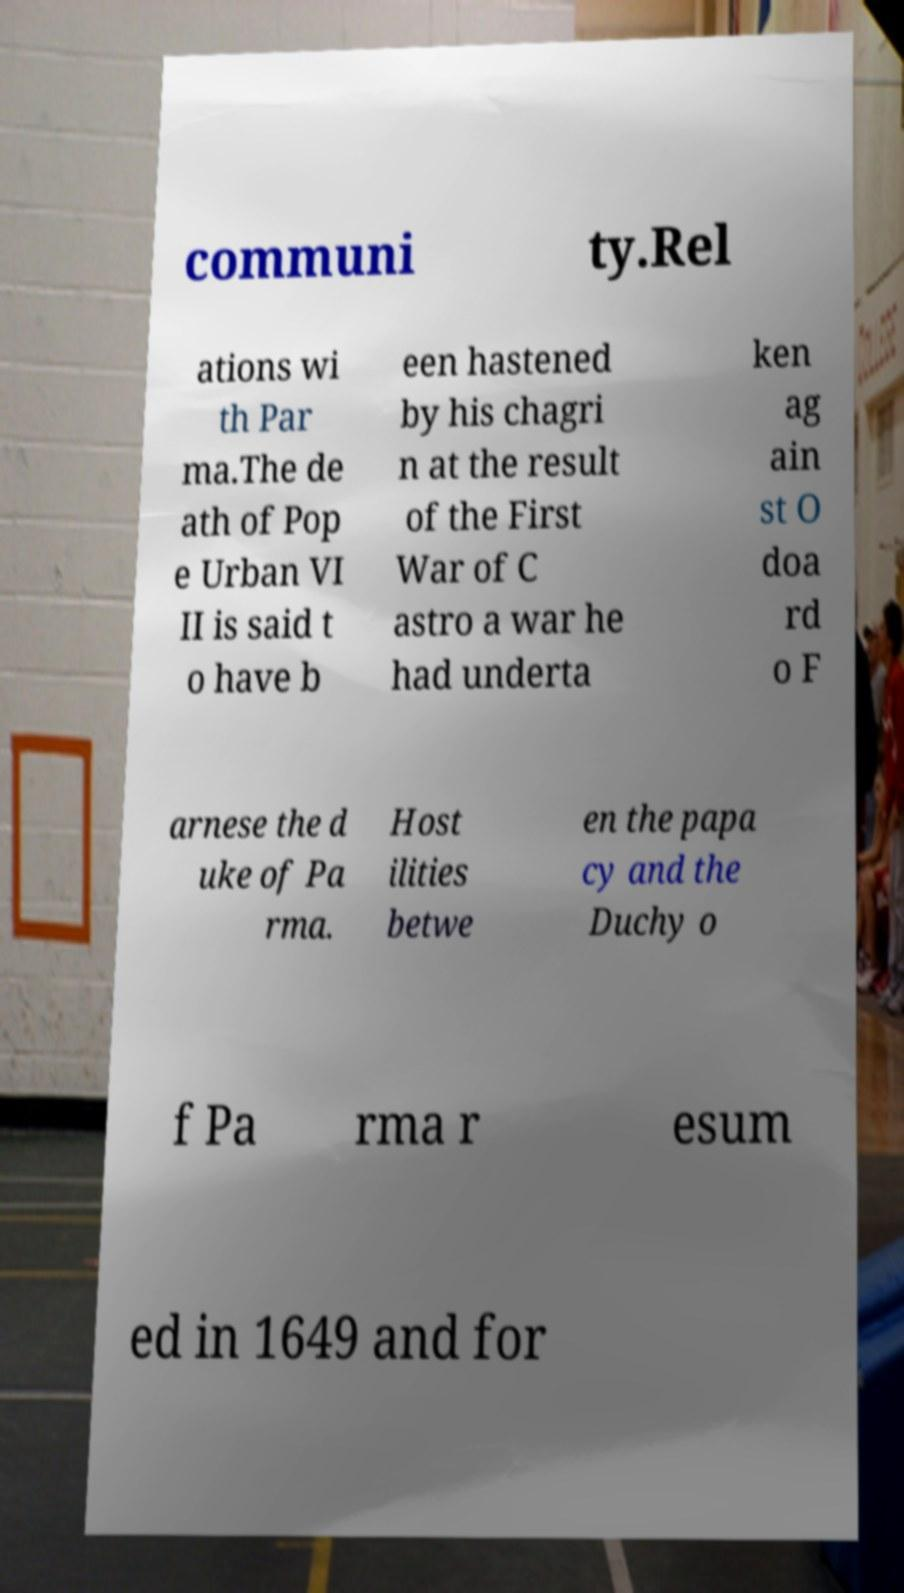Could you extract and type out the text from this image? communi ty.Rel ations wi th Par ma.The de ath of Pop e Urban VI II is said t o have b een hastened by his chagri n at the result of the First War of C astro a war he had underta ken ag ain st O doa rd o F arnese the d uke of Pa rma. Host ilities betwe en the papa cy and the Duchy o f Pa rma r esum ed in 1649 and for 